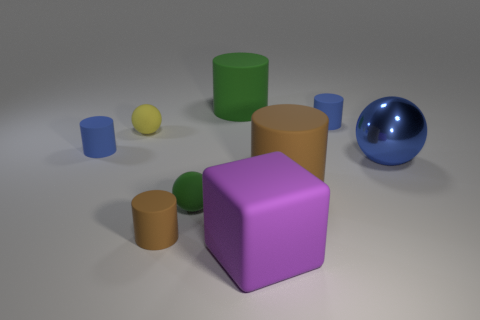There is a matte block; is its color the same as the tiny rubber object behind the tiny yellow matte object?
Provide a succinct answer. No. Are there any green rubber balls behind the metal thing?
Your answer should be very brief. No. There is a blue object on the left side of the block; does it have the same size as the yellow ball that is on the left side of the green matte ball?
Offer a very short reply. Yes. Is there a gray cylinder that has the same size as the blue metallic thing?
Your answer should be very brief. No. There is a brown rubber thing that is on the right side of the large purple matte block; is its shape the same as the large blue object?
Your answer should be very brief. No. What material is the ball left of the green sphere?
Keep it short and to the point. Rubber. There is a tiny blue matte thing that is behind the small blue matte cylinder that is in front of the tiny yellow rubber thing; what shape is it?
Keep it short and to the point. Cylinder. Is the shape of the blue shiny thing the same as the blue matte object that is on the left side of the cube?
Ensure brevity in your answer.  No. There is a purple cube in front of the blue metal object; how many big blue metal balls are on the left side of it?
Provide a short and direct response. 0. There is a large blue object that is the same shape as the yellow thing; what is it made of?
Your answer should be compact. Metal. 